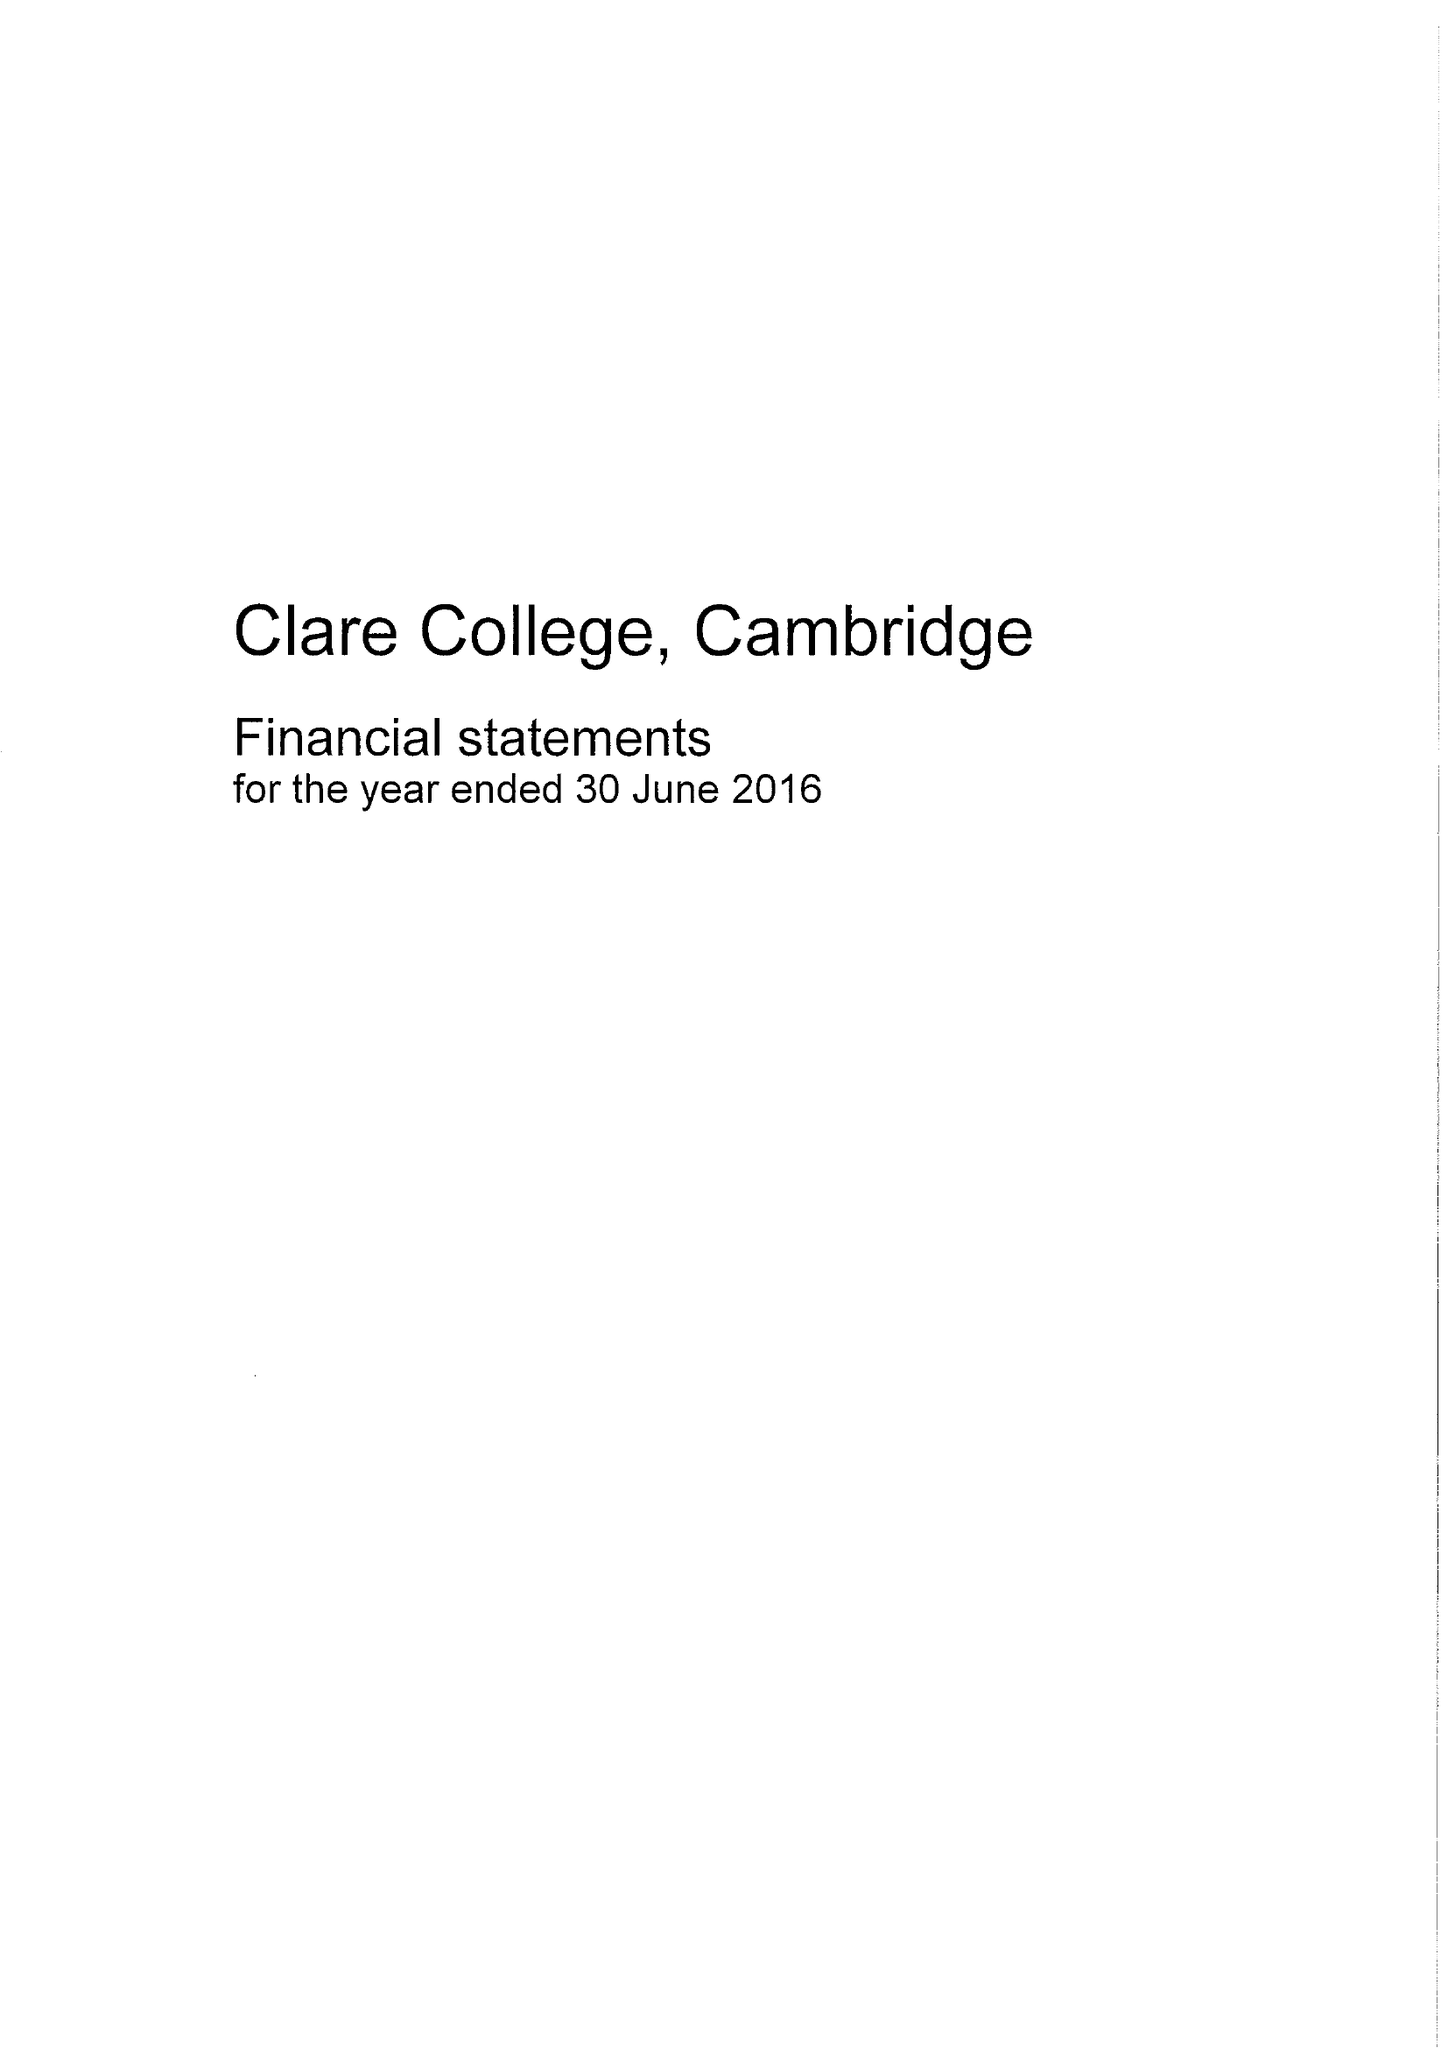What is the value for the address__postcode?
Answer the question using a single word or phrase. CB2 1TL 